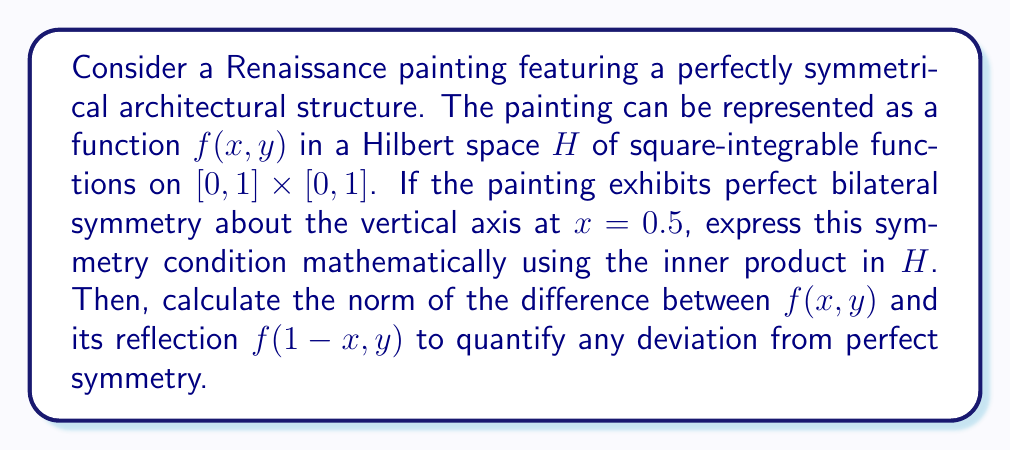Help me with this question. To approach this problem, we'll follow these steps:

1) In a Hilbert space $H$ of square-integrable functions on $[0, 1] \times [0, 1]$, the inner product is defined as:

   $$(f, g) = \int_0^1 \int_0^1 f(x,y)g(x,y) dx dy$$

2) For perfect bilateral symmetry about $x = 0.5$, we should have:

   $$f(x, y) = f(1-x, y)$$ for all $x, y \in [0, 1]$

3) To express this symmetry condition using the inner product, we can state that the function should be equal to its reflection when projected onto any other function in the space. Mathematically:

   $$(f, g) = (f_r, g)$$ for all $g \in H$, where $f_r(x,y) = f(1-x, y)$

4) To quantify deviation from perfect symmetry, we can calculate the norm of the difference between $f$ and $f_r$:

   $$\|f - f_r\| = \sqrt{(f-f_r, f-f_r)}$$

5) Expanding this:

   $$\|f - f_r\|^2 = (f-f_r, f-f_r) = (f,f) + (f_r,f_r) - 2(f,f_r)$$

6) Note that $(f_r,f_r) = (f,f)$ because the integral is invariant under the transformation $x \to 1-x$. So:

   $$\|f - f_r\|^2 = 2(f,f) - 2(f,f_r)$$

7) For perfect symmetry, this norm should be zero. Any non-zero value indicates a deviation from perfect symmetry.

This approach allows us to quantify the symmetry of Renaissance artworks using functional analysis techniques, bridging the gap between mathematical rigor and artistic appreciation.
Answer: The symmetry condition expressed using the inner product in $H$ is:

$$(f, g) = (f_r, g)$$ for all $g \in H$, where $f_r(x,y) = f(1-x, y)$

The norm quantifying deviation from perfect symmetry is:

$$\|f - f_r\| = \sqrt{2(f,f) - 2(f,f_r)}$$

Perfect symmetry is achieved when this norm equals zero. 